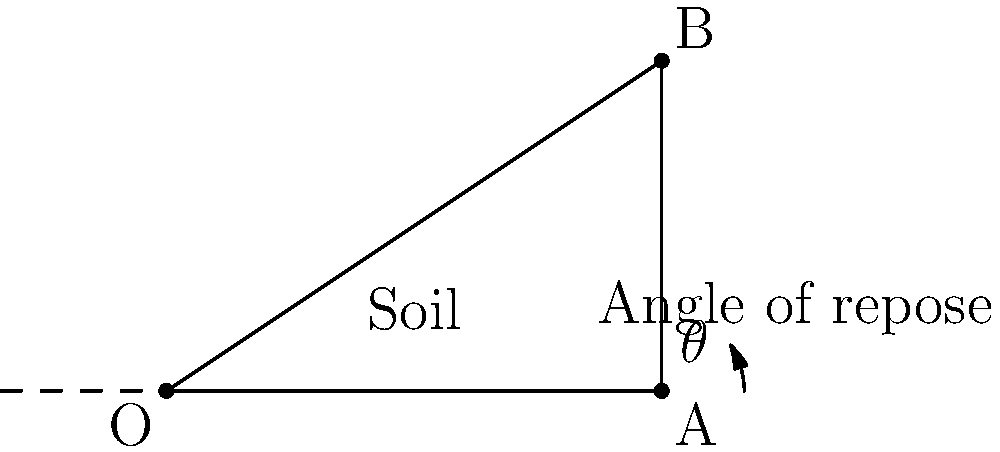In an archaeological excavation, the angle of repose for the soil is found to be $\theta = \arctan(2/3)$. If the excavation depth is 3 meters, what is the minimum horizontal distance required from the edge of the dig to ensure soil stability and preserve the integrity of the site? To solve this problem, we'll follow these steps:

1) The angle of repose ($\theta$) is given by $\arctan(2/3)$.

2) In the diagram, we have a right-angled triangle OAB, where:
   - OA represents the horizontal distance we need to find
   - AB represents the excavation depth (3 meters)
   - Angle BAO is the angle of repose ($\theta$)

3) We can use the tangent function to relate these sides:

   $\tan(\theta) = \frac{\text{opposite}}{\text{adjacent}} = \frac{AB}{OA} = \frac{3}{OA}$

4) We're given that $\tan(\theta) = \frac{2}{3}$, so we can set up the equation:

   $\frac{2}{3} = \frac{3}{OA}$

5) Cross multiply:

   $2 \cdot OA = 3 \cdot 3$

6) Solve for OA:

   $OA = \frac{3 \cdot 3}{2} = \frac{9}{2} = 4.5$

Therefore, the minimum horizontal distance required from the edge of the dig is 4.5 meters.
Answer: 4.5 meters 